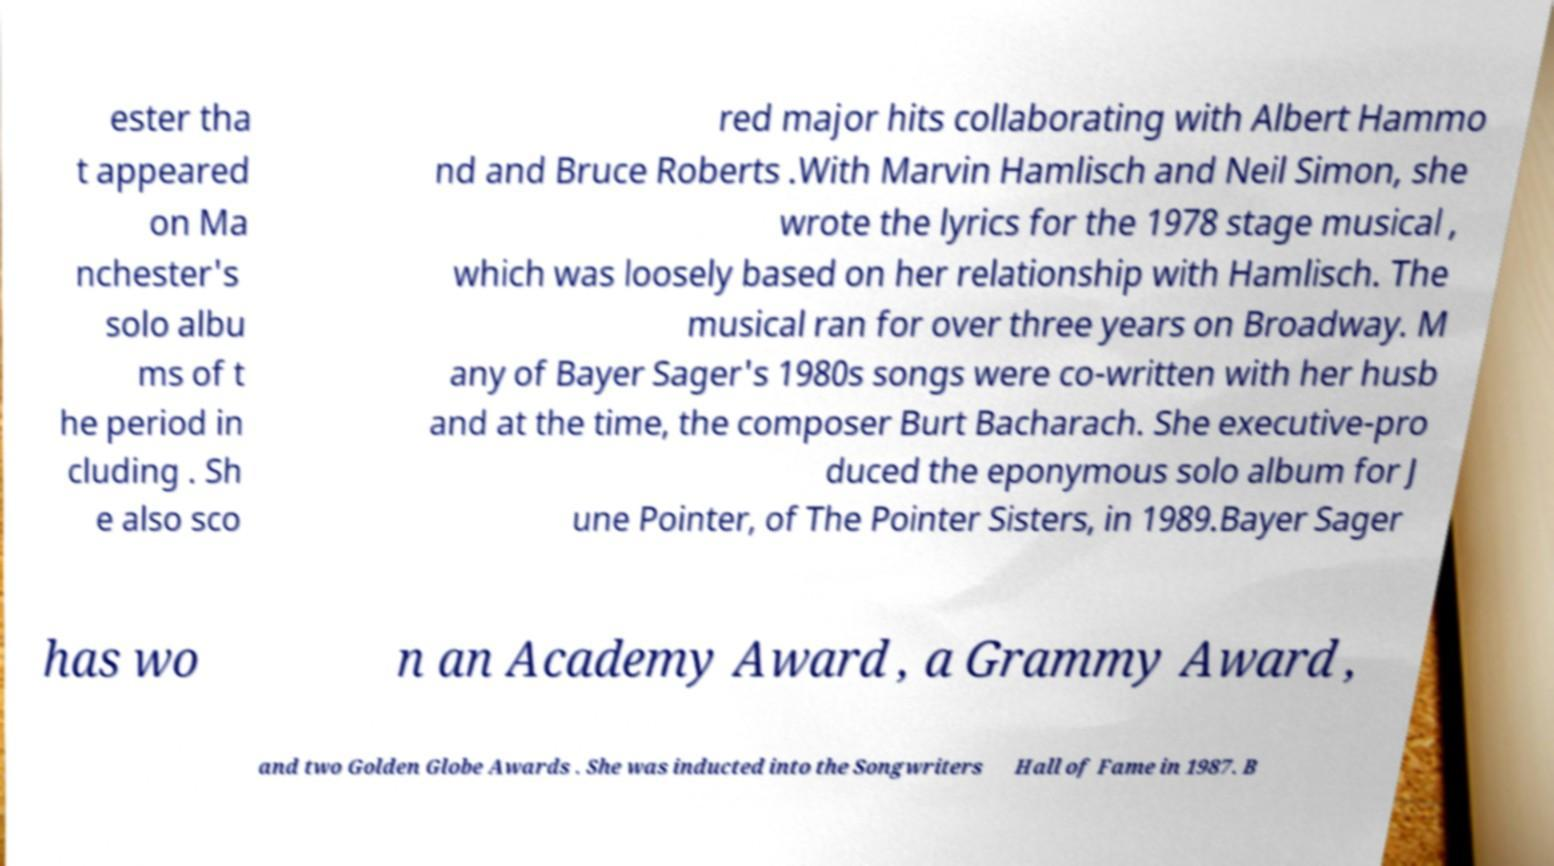For documentation purposes, I need the text within this image transcribed. Could you provide that? ester tha t appeared on Ma nchester's solo albu ms of t he period in cluding . Sh e also sco red major hits collaborating with Albert Hammo nd and Bruce Roberts .With Marvin Hamlisch and Neil Simon, she wrote the lyrics for the 1978 stage musical , which was loosely based on her relationship with Hamlisch. The musical ran for over three years on Broadway. M any of Bayer Sager's 1980s songs were co-written with her husb and at the time, the composer Burt Bacharach. She executive-pro duced the eponymous solo album for J une Pointer, of The Pointer Sisters, in 1989.Bayer Sager has wo n an Academy Award , a Grammy Award , and two Golden Globe Awards . She was inducted into the Songwriters Hall of Fame in 1987. B 